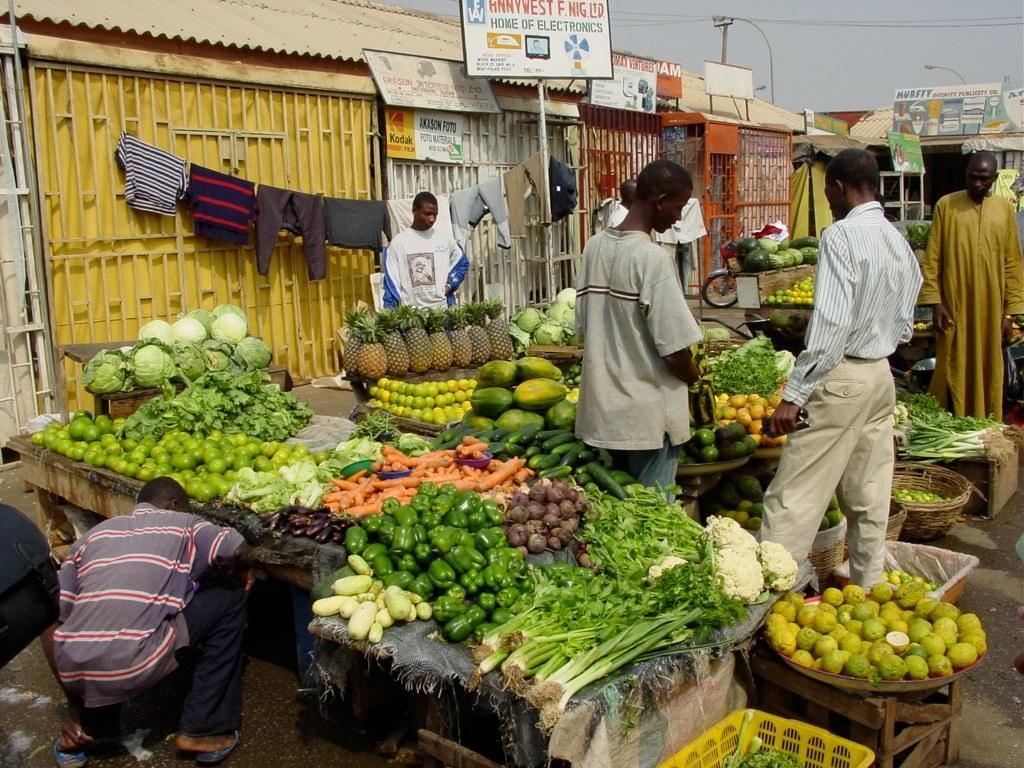Can you describe this image briefly? In this image I can see people, few boards, clothes and on these boards I can see something is written. I can also see few basket, few tables and different types vegetable. I can also see few fruits and in background I can see a board, few wires and street light. 